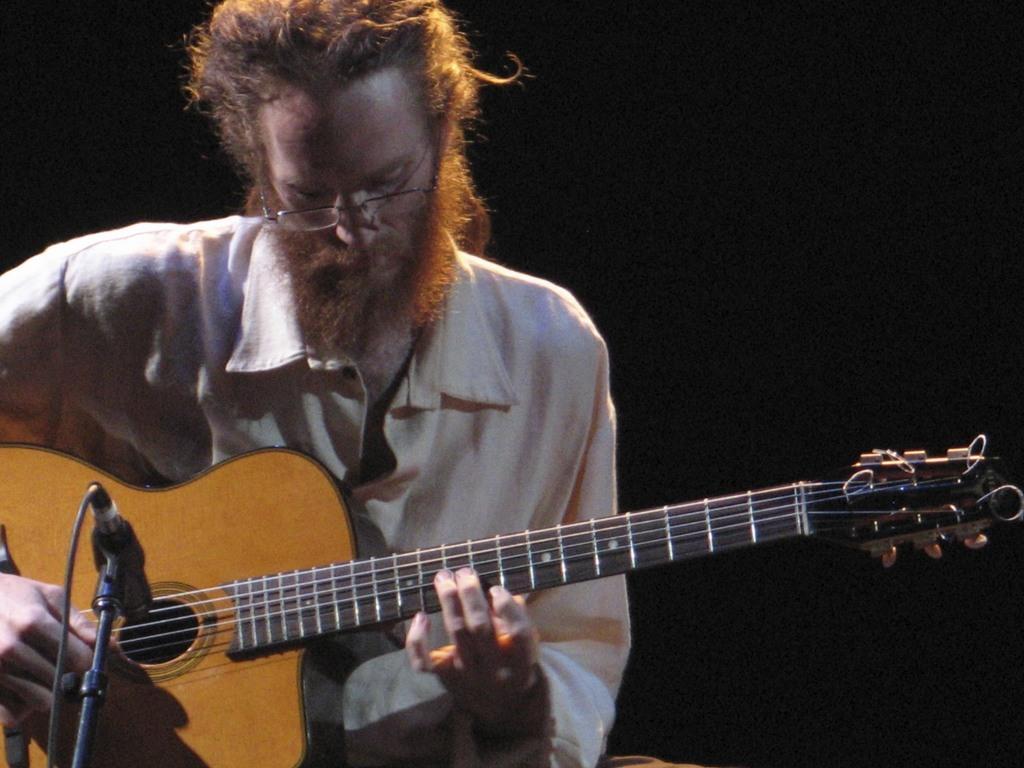How would you summarize this image in a sentence or two? In this image there is a person wearing white color shirt playing a guitar and there is also a microphone at the left side of the image. 